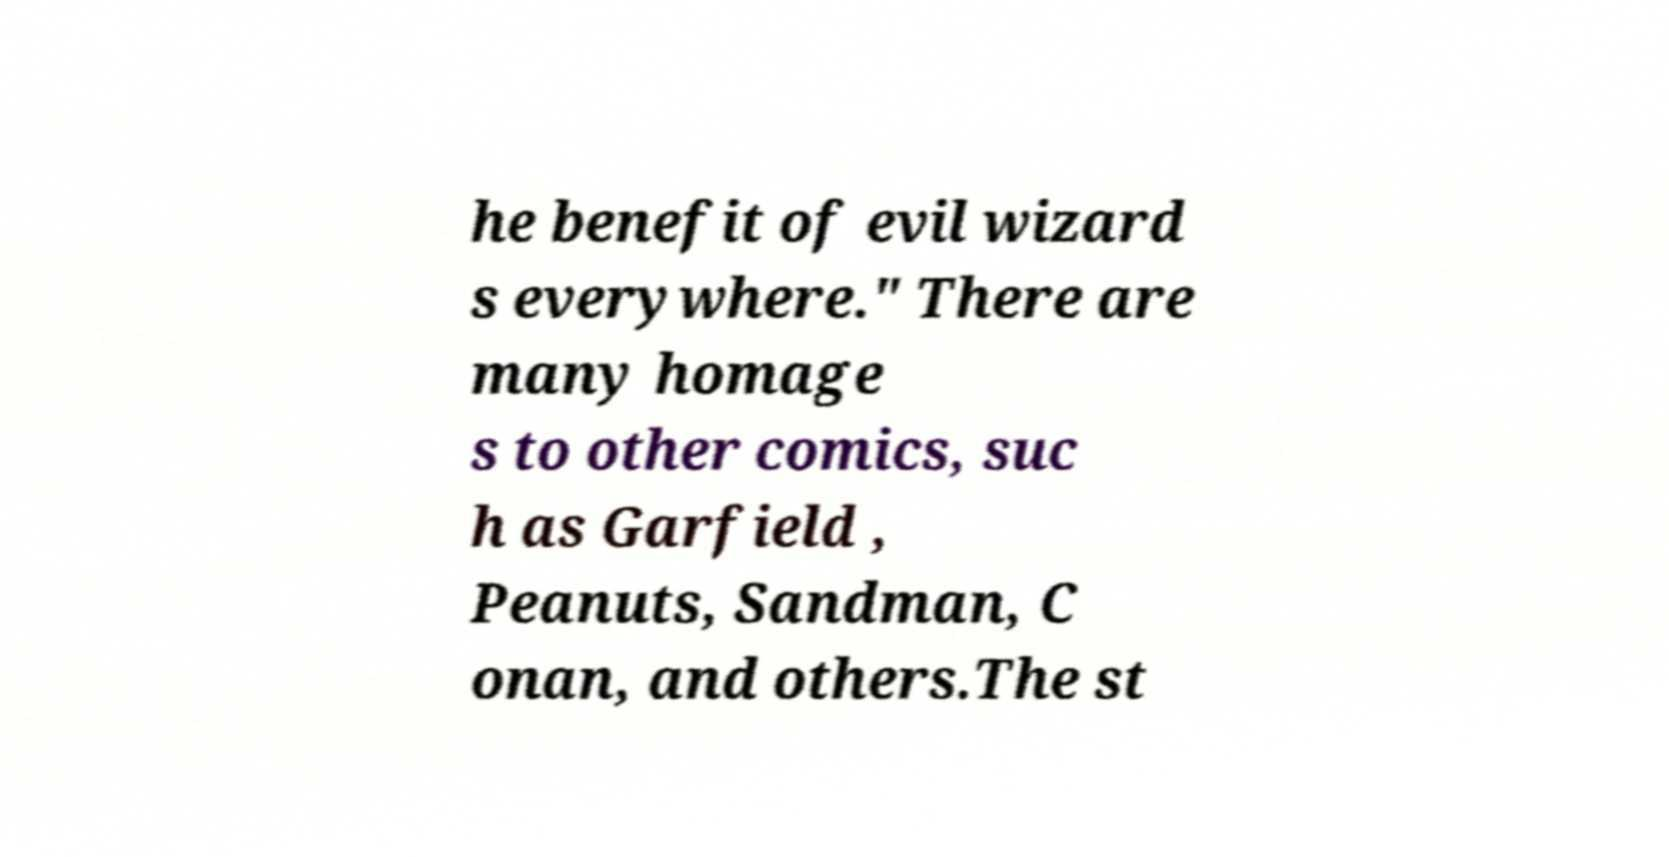Could you extract and type out the text from this image? he benefit of evil wizard s everywhere." There are many homage s to other comics, suc h as Garfield , Peanuts, Sandman, C onan, and others.The st 